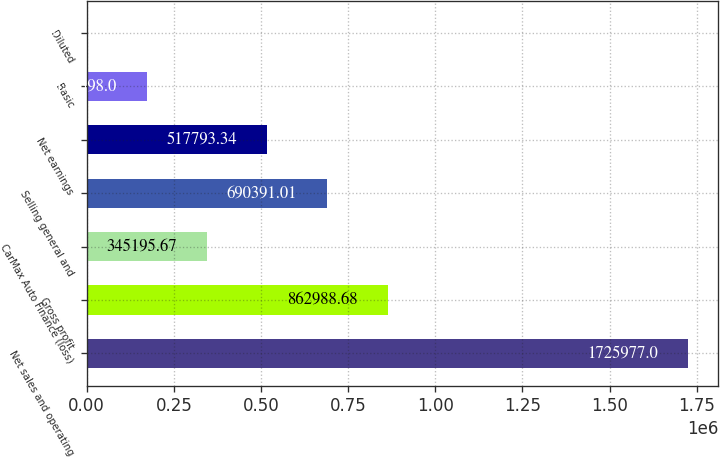Convert chart. <chart><loc_0><loc_0><loc_500><loc_500><bar_chart><fcel>Net sales and operating<fcel>Gross profit<fcel>CarMax Auto Finance (loss)<fcel>Selling general and<fcel>Net earnings<fcel>Basic<fcel>Diluted<nl><fcel>1.72598e+06<fcel>862989<fcel>345196<fcel>690391<fcel>517793<fcel>172598<fcel>0.33<nl></chart> 